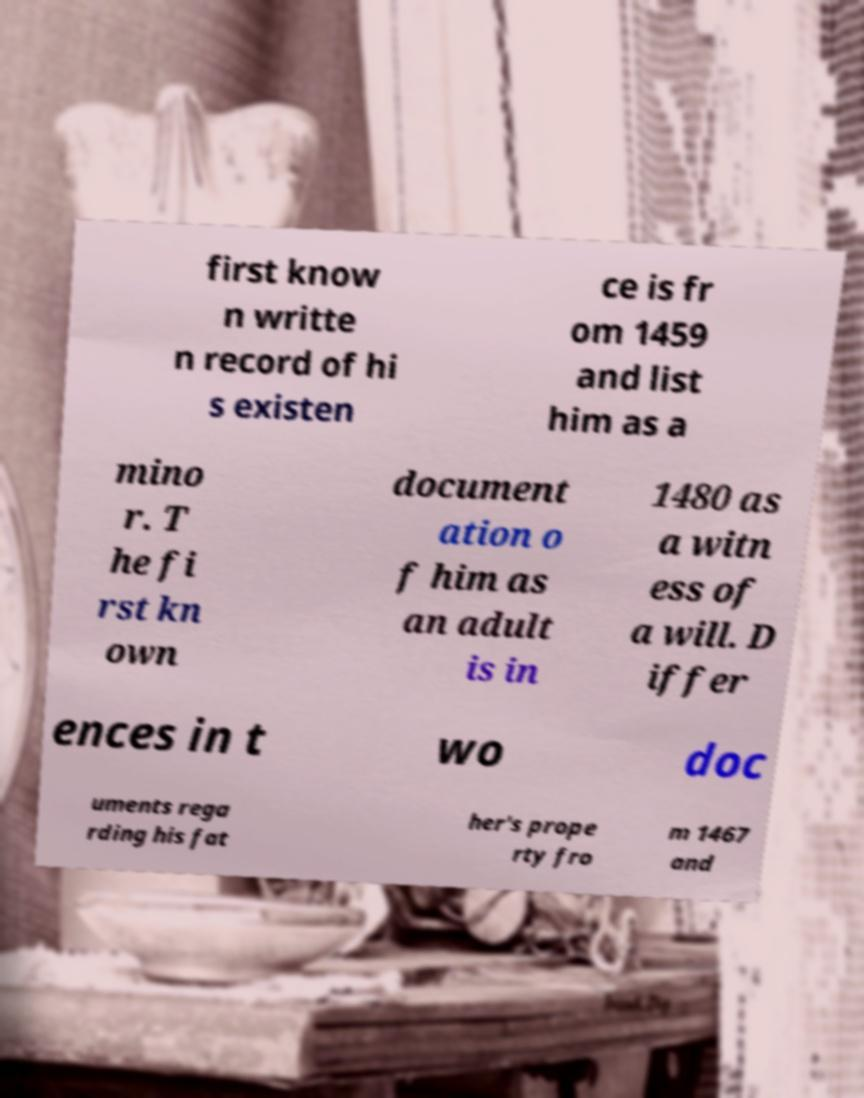What messages or text are displayed in this image? I need them in a readable, typed format. first know n writte n record of hi s existen ce is fr om 1459 and list him as a mino r. T he fi rst kn own document ation o f him as an adult is in 1480 as a witn ess of a will. D iffer ences in t wo doc uments rega rding his fat her's prope rty fro m 1467 and 